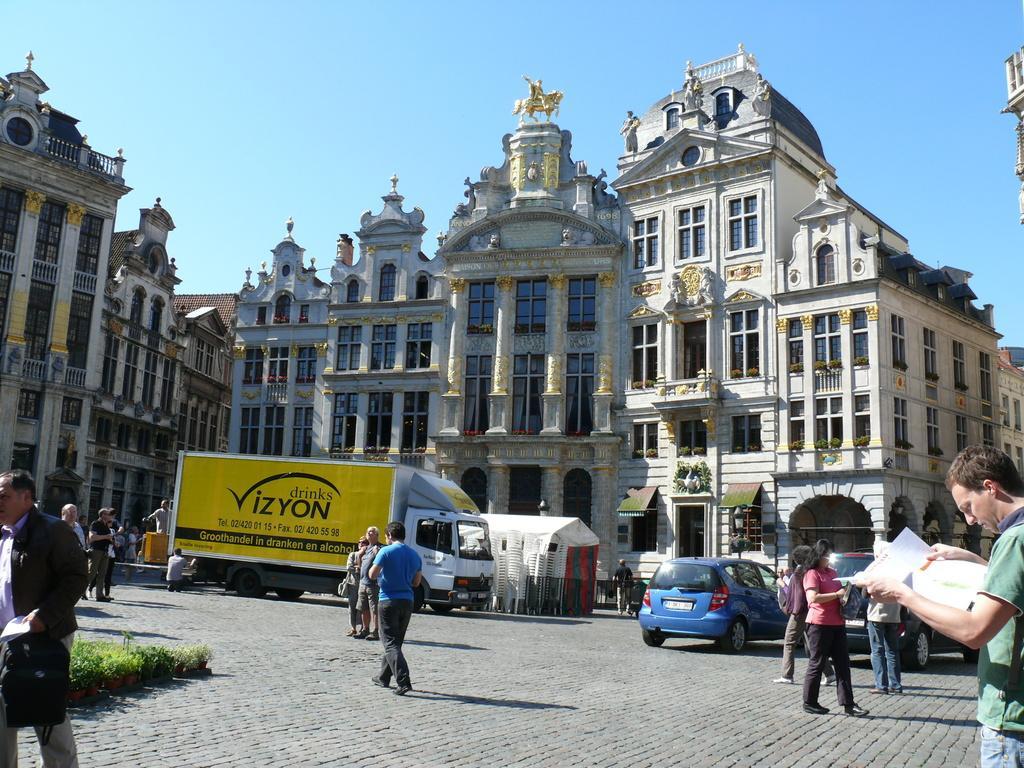Could you give a brief overview of what you see in this image? In this picture we can see a group of people walking on the path and a man is holding a paper. In front of the people there are some vehicles on the path and chairs. Behind the vehicles there are buildings and a sky. 